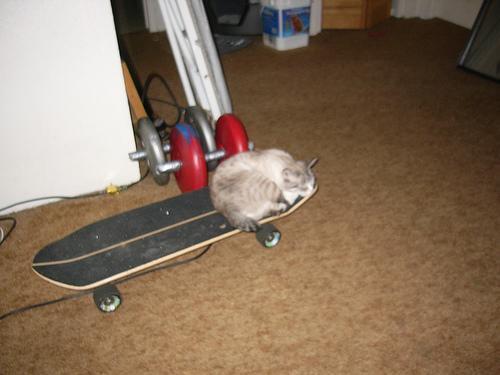How many dumbbells are there?
Give a very brief answer. 2. How many cats are there?
Give a very brief answer. 1. How many wheels are visible?
Give a very brief answer. 2. 